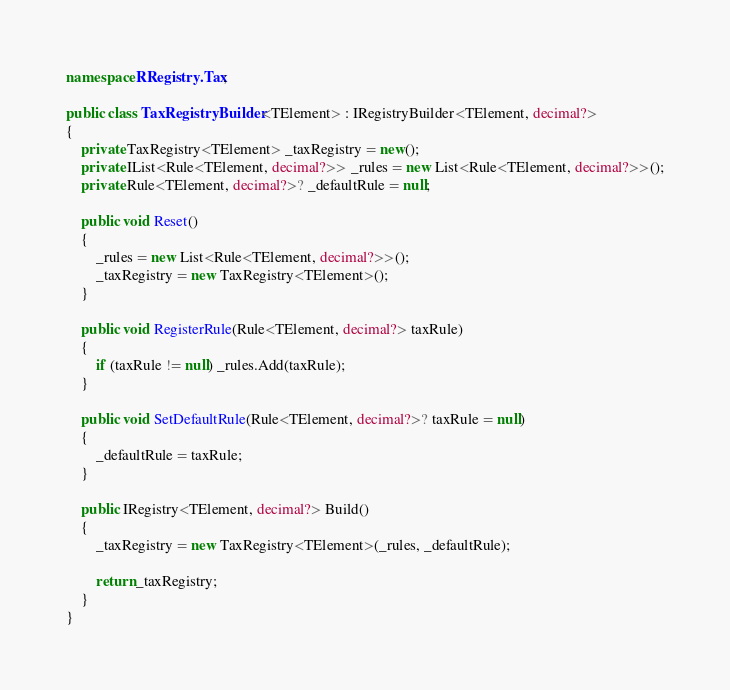Convert code to text. <code><loc_0><loc_0><loc_500><loc_500><_C#_>namespace RRegistry.Tax;

public class TaxRegistryBuilder<TElement> : IRegistryBuilder<TElement, decimal?>
{
    private TaxRegistry<TElement> _taxRegistry = new();
    private IList<Rule<TElement, decimal?>> _rules = new List<Rule<TElement, decimal?>>();
    private Rule<TElement, decimal?>? _defaultRule = null;

    public void Reset()
    {
        _rules = new List<Rule<TElement, decimal?>>();
        _taxRegistry = new TaxRegistry<TElement>();
    }

    public void RegisterRule(Rule<TElement, decimal?> taxRule)
    {
        if (taxRule != null) _rules.Add(taxRule);
    }

    public void SetDefaultRule(Rule<TElement, decimal?>? taxRule = null)
    {
        _defaultRule = taxRule;
    }

    public IRegistry<TElement, decimal?> Build()
    {
        _taxRegistry = new TaxRegistry<TElement>(_rules, _defaultRule);

        return _taxRegistry;
    }
}</code> 